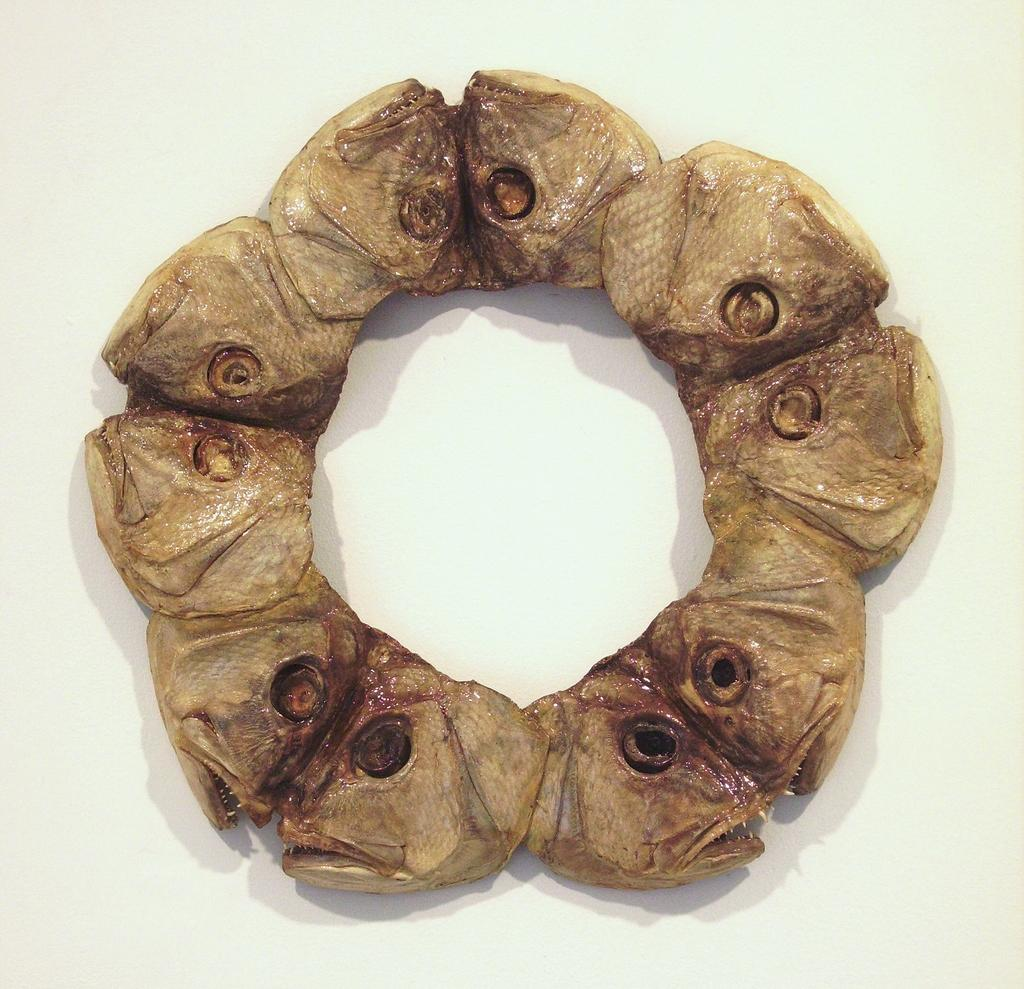What type of food is depicted in the image? The image contains fish heads. How are the fish heads prepared? The fish heads appear to be roasted. What color are the fish heads in the image? The fish heads are in brown color. What type of insurance policy is advertised on the fish heads in the image? There is no insurance policy advertised on the fish heads in the image; it only contains roasted fish heads. 